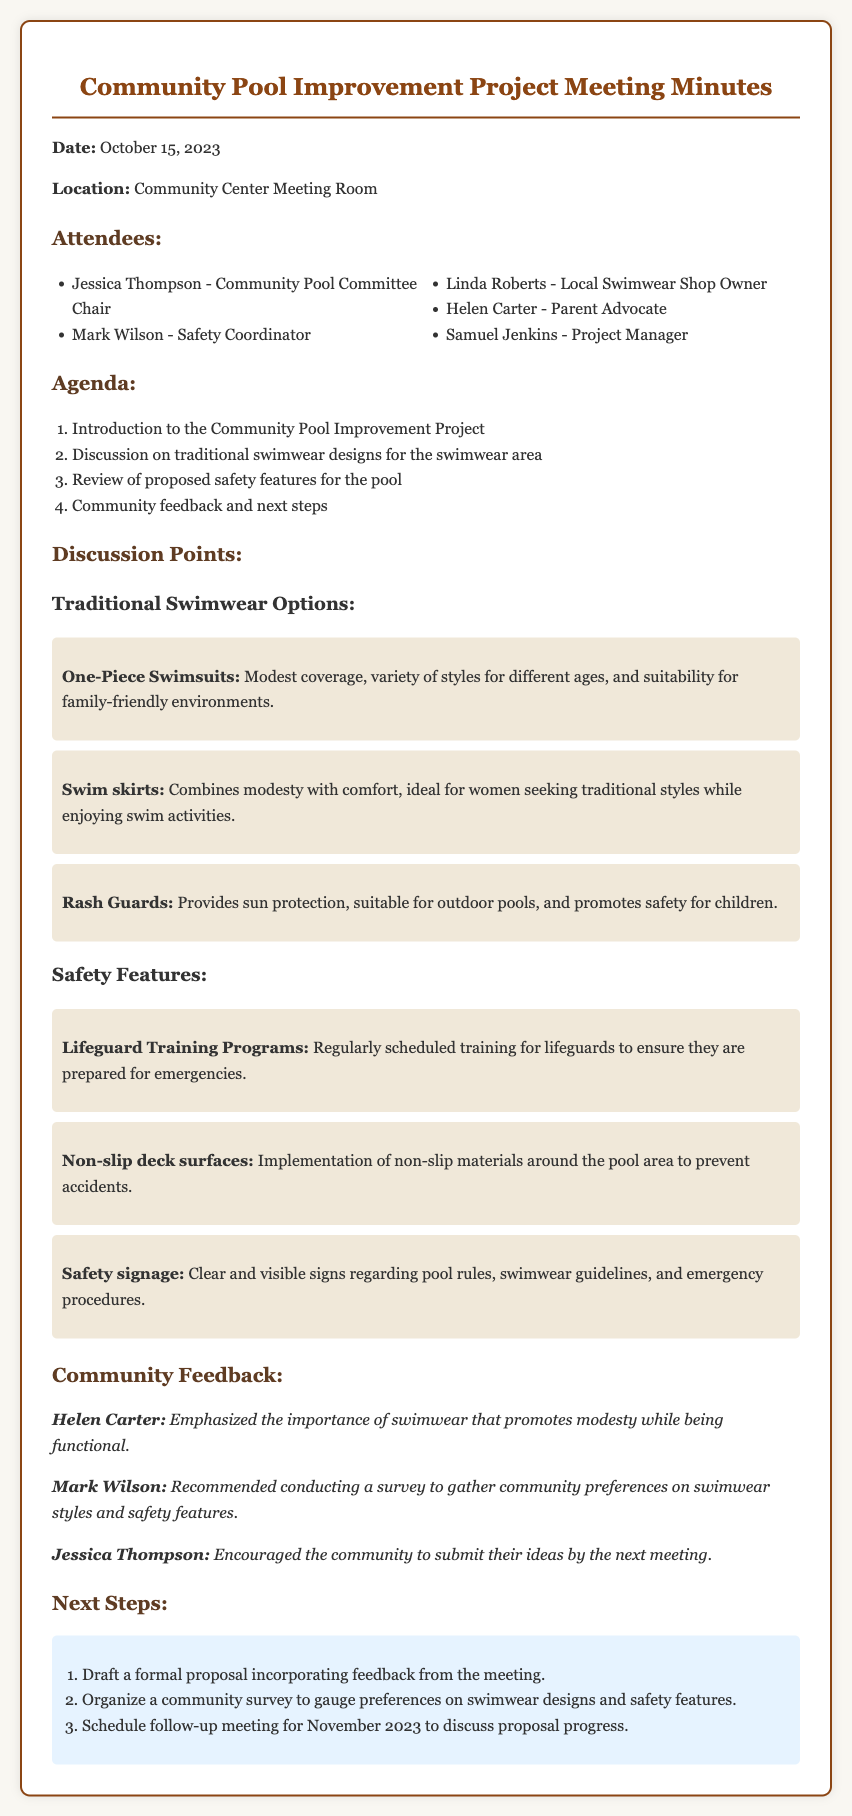what is the date of the meeting? The date of the meeting is clearly stated in the first part of the document as October 15, 2023.
Answer: October 15, 2023 who is the Community Pool Committee Chair? The name of the Community Pool Committee Chair is mentioned in the attendees section of the document.
Answer: Jessica Thompson what types of traditional swimwear were discussed? The document lists specific styles of traditional swimwear in the discussion points section.
Answer: One-Piece Swimsuits, Swim skirts, Rash Guards what safety feature involves training? One of the safety features discussed relates to the training aspects of pool safety.
Answer: Lifeguard Training Programs who emphasized the importance of modest swimwear? A specific attendee mentioned the need for swimwear that promotes modesty during the community feedback section.
Answer: Helen Carter how many attendees were listed in the document? The document includes a list of people who attended the meeting, totaling their names.
Answer: Five what is one proposed safety feature for the pool area? The discussion points outline several safety features proposed for the pool area.
Answer: Non-slip deck surfaces what is the next scheduled meeting month? The next steps section indicates when the follow-up meeting is planned based on the community feedback.
Answer: November 2023 